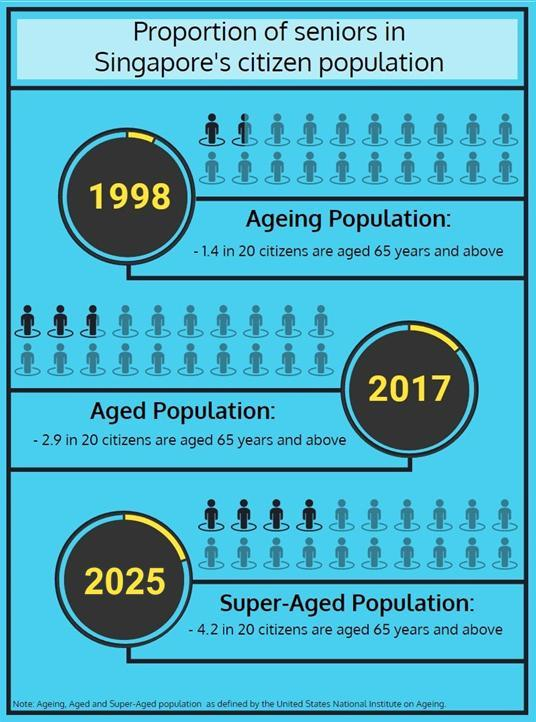what was the percentage of senior citizens of Singapore in 1998?
Answer the question with a short phrase. 7 what was the percentage of senior citizens of Singapore in 2017? 14.5% what is the expected percentage of senior citizens of Singapore in 2025? 21% 